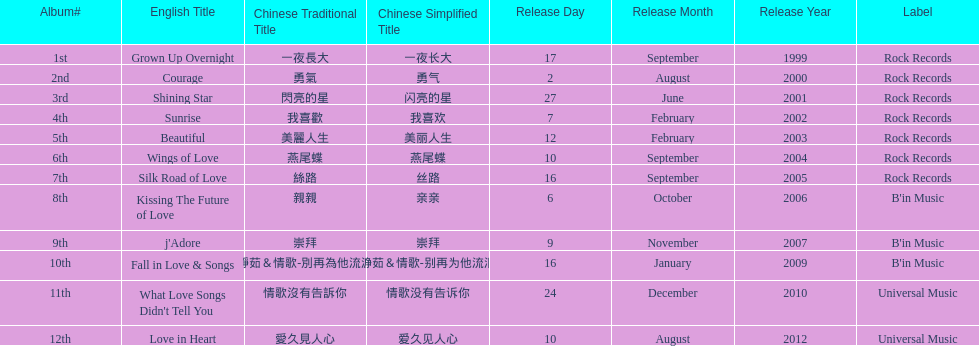Which album was released later, beautiful, or j'adore? J'adore. 